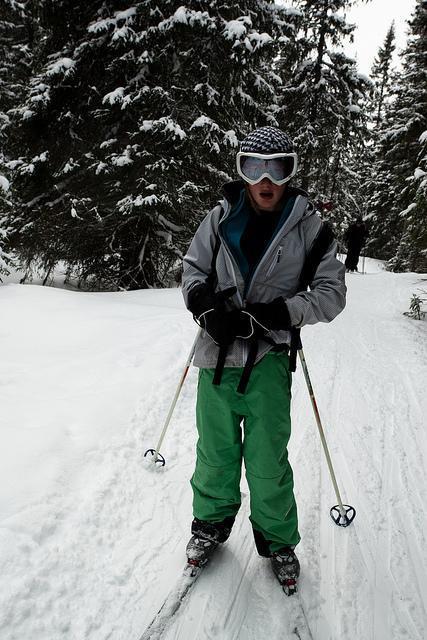How many sinks are there?
Give a very brief answer. 0. 